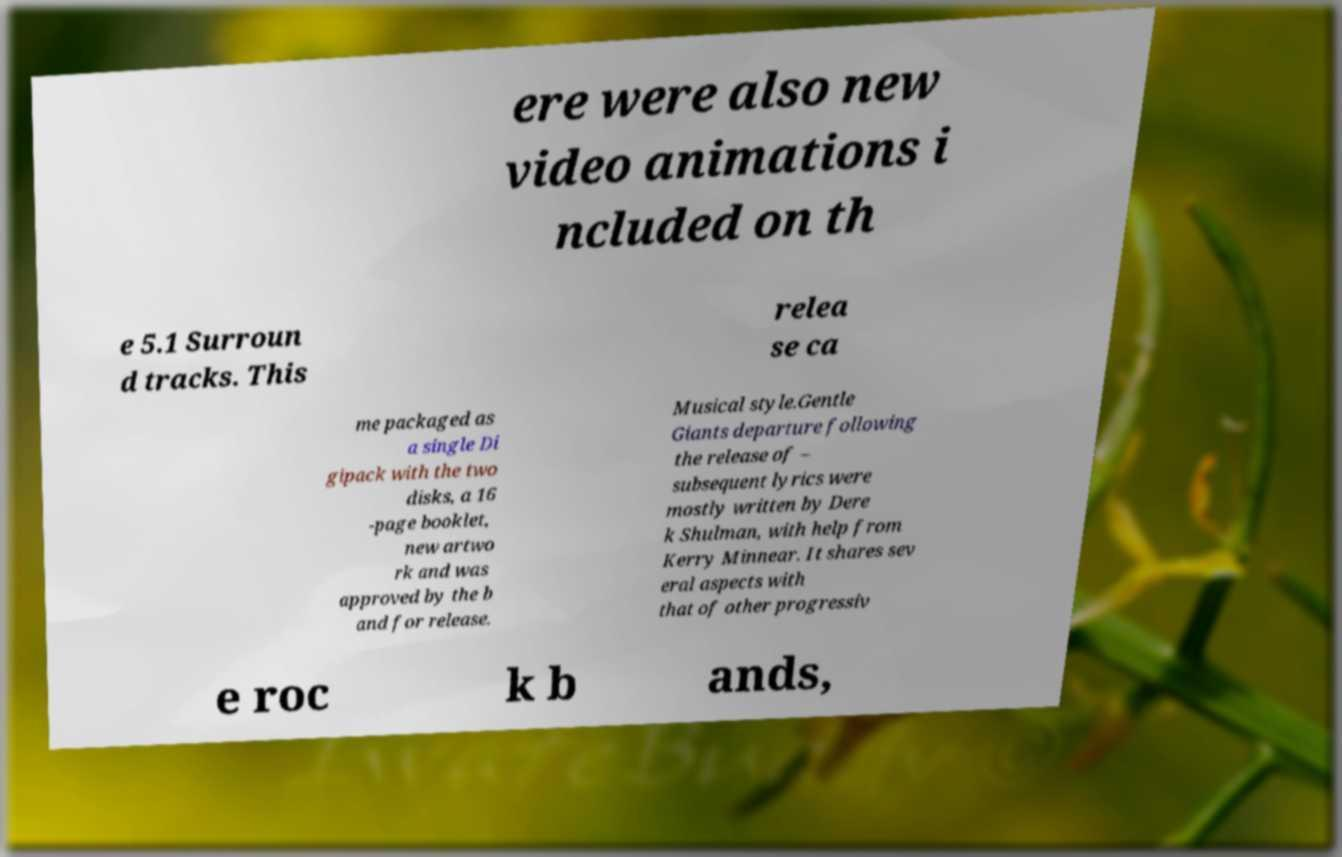Please identify and transcribe the text found in this image. ere were also new video animations i ncluded on th e 5.1 Surroun d tracks. This relea se ca me packaged as a single Di gipack with the two disks, a 16 -page booklet, new artwo rk and was approved by the b and for release. Musical style.Gentle Giants departure following the release of – subsequent lyrics were mostly written by Dere k Shulman, with help from Kerry Minnear. It shares sev eral aspects with that of other progressiv e roc k b ands, 